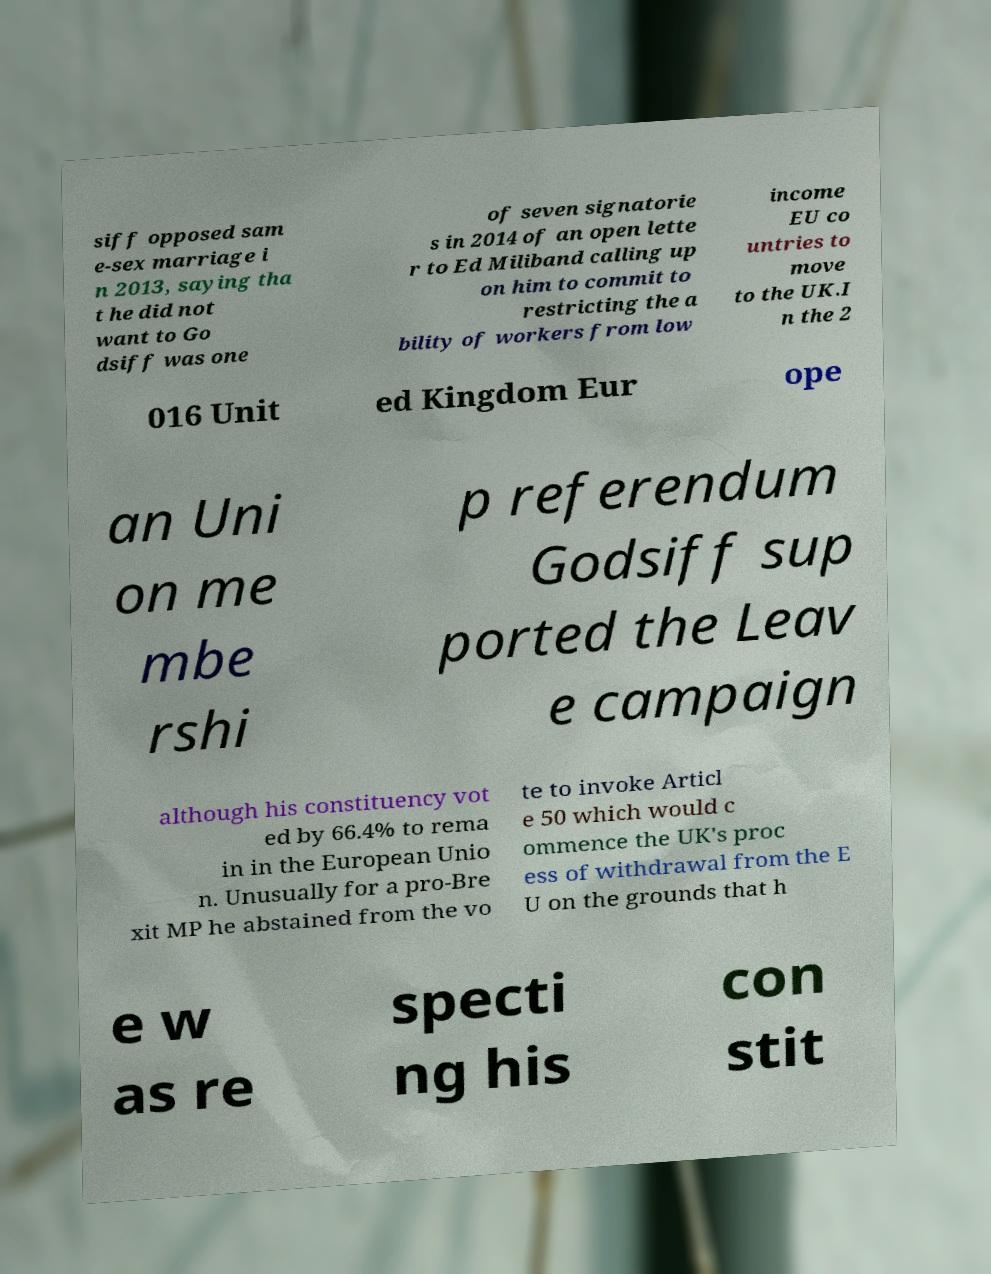Please identify and transcribe the text found in this image. siff opposed sam e-sex marriage i n 2013, saying tha t he did not want to Go dsiff was one of seven signatorie s in 2014 of an open lette r to Ed Miliband calling up on him to commit to restricting the a bility of workers from low income EU co untries to move to the UK.I n the 2 016 Unit ed Kingdom Eur ope an Uni on me mbe rshi p referendum Godsiff sup ported the Leav e campaign although his constituency vot ed by 66.4% to rema in in the European Unio n. Unusually for a pro-Bre xit MP he abstained from the vo te to invoke Articl e 50 which would c ommence the UK's proc ess of withdrawal from the E U on the grounds that h e w as re specti ng his con stit 